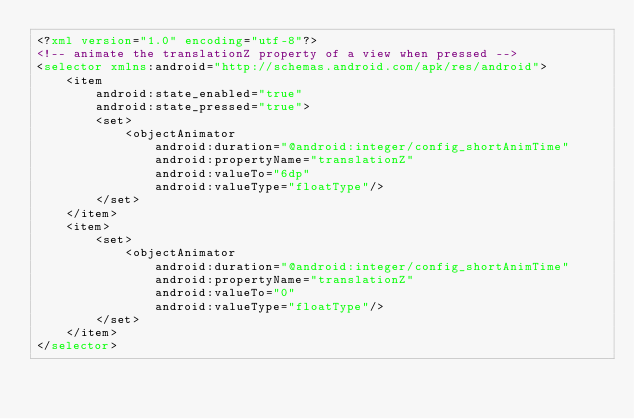<code> <loc_0><loc_0><loc_500><loc_500><_XML_><?xml version="1.0" encoding="utf-8"?>
<!-- animate the translationZ property of a view when pressed -->
<selector xmlns:android="http://schemas.android.com/apk/res/android">
    <item
        android:state_enabled="true"
        android:state_pressed="true">
        <set>
            <objectAnimator
                android:duration="@android:integer/config_shortAnimTime"
                android:propertyName="translationZ"
                android:valueTo="6dp"
                android:valueType="floatType"/>
        </set>
    </item>
    <item>
        <set>
            <objectAnimator
                android:duration="@android:integer/config_shortAnimTime"
                android:propertyName="translationZ"
                android:valueTo="0"
                android:valueType="floatType"/>
        </set>
    </item>
</selector></code> 